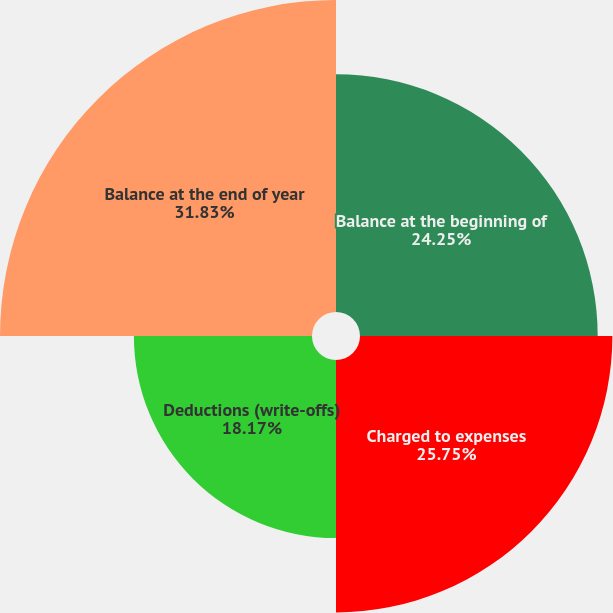Convert chart to OTSL. <chart><loc_0><loc_0><loc_500><loc_500><pie_chart><fcel>Balance at the beginning of<fcel>Charged to expenses<fcel>Deductions (write-offs)<fcel>Balance at the end of year<nl><fcel>24.25%<fcel>25.75%<fcel>18.17%<fcel>31.83%<nl></chart> 